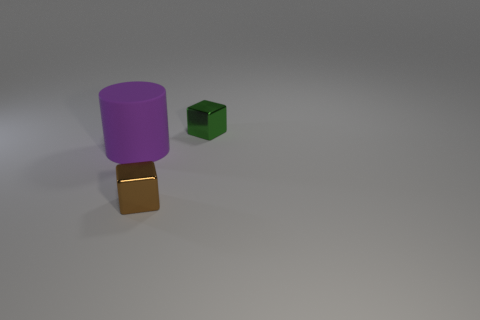Subtract all cubes. How many objects are left? 1 Add 2 small matte things. How many objects exist? 5 Add 3 tiny blue shiny blocks. How many tiny blue shiny blocks exist? 3 Subtract 0 green cylinders. How many objects are left? 3 Subtract all large matte things. Subtract all large purple matte objects. How many objects are left? 1 Add 2 large purple rubber objects. How many large purple rubber objects are left? 3 